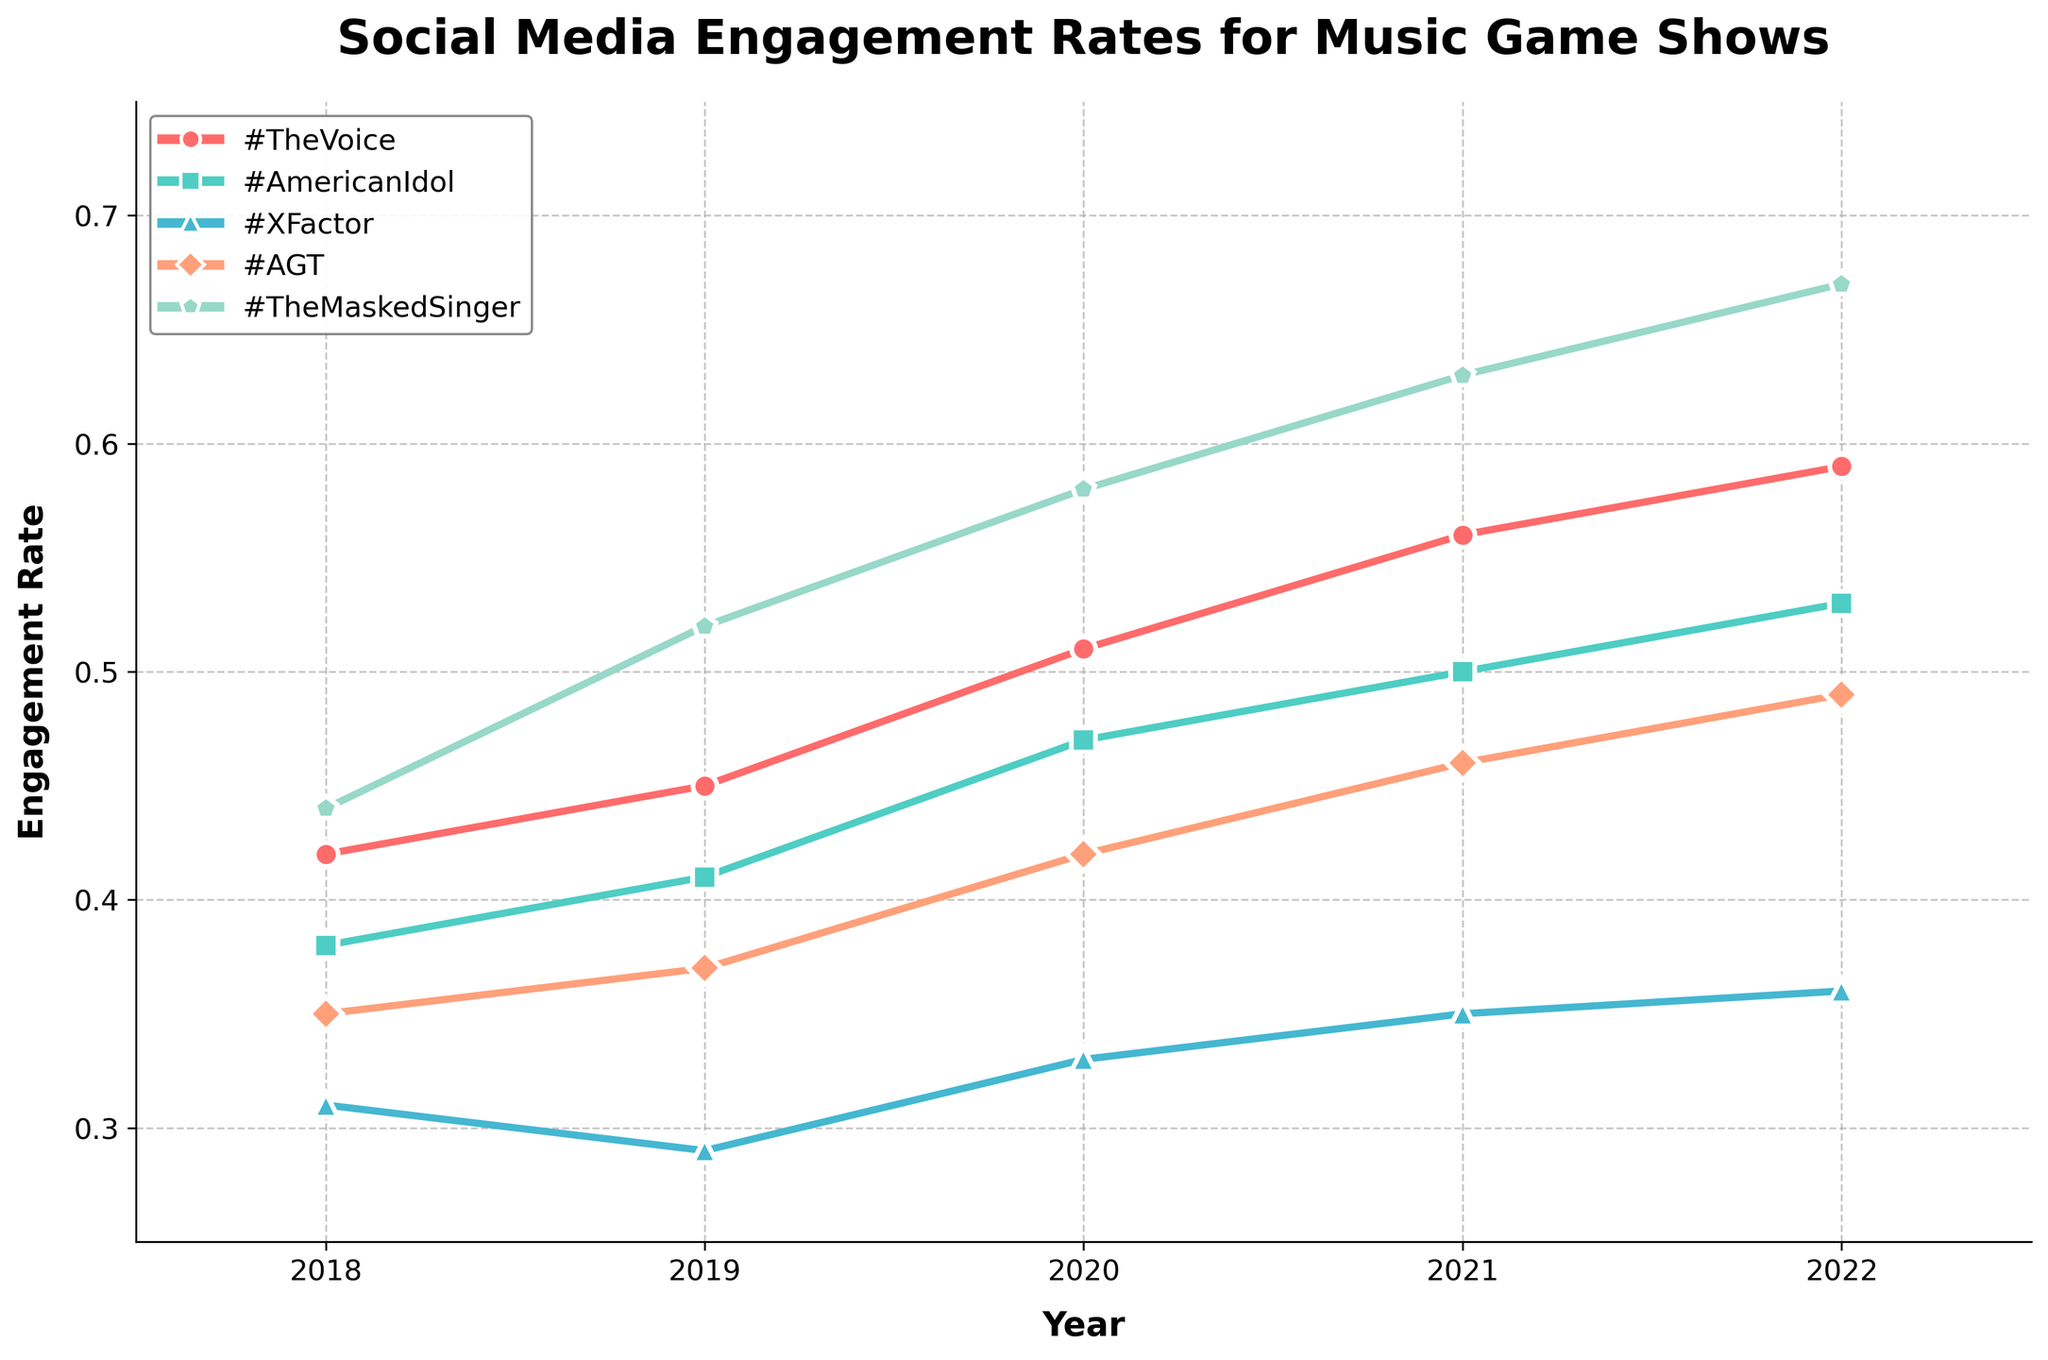What's the trend of the engagement rate for #TheVoice over the years? The engagement rate for #TheVoice shows an increasing trend over the years. By examining the line representing #TheVoice, we see that it starts from a lower value in 2018 and consistently goes up each year, reaching higher values in 2022.
Answer: Increasing Which show had the highest engagement rate in 2022? Looking at the engagement rates for different shows in 2022, #TheMaskedSinger has the highest engagement rate because its line ends at the topmost position compared to the others.
Answer: #TheMaskedSinger Between #AmericanIdol and #XFactor, which show had a lower engagement rate in 2020? Comparing the points for #AmericanIdol and #XFactor in the year 2020, the engagement rate for #XFactor is lower because its point is visibly below the point for #AmericanIdol.
Answer: #XFactor What is the average engagement rate for #AGT from 2018 to 2022? To find the average, sum the engagement rates for #AGT over the years: (0.35 + 0.37 + 0.42 + 0.46 + 0.49) = 2.09. Then divide by the number of years, 5. 2.09 / 5 = 0.418.
Answer: 0.418 In which year did #TheMaskedSinger see the greatest increase in engagement rate compared to the previous year? Calculate the year-over-year increase: 2019-2018 (0.52-0.44 = 0.08), 2020-2019 (0.58-0.52 = 0.06), 2021-2020 (0.63-0.58 = 0.05), 2022-2021 (0.67-0.63 = 0.04). The greatest increase is from 2018 to 2019, which is 0.08.
Answer: 2019 Which show has the most consistent engagement rate over the years? Consistency can be gauged through the least fluctuation in points over the years. By visual inspection, #XFactor appears to have the most consistent, nearly straight, and least varied line among all the shows.
Answer: #XFactor How much higher was the engagement rate for #TheVoice compared to #AGT in 2021? The engagement rate for #TheVoice in 2021 was 0.56, and for #AGT it was 0.46. The difference is 0.56 - 0.46 = 0.10.
Answer: 0.10 What was the lowest engagement rate recorded across all shows from 2018 to 2022? To find the lowest engagement rate, observe all the points and lines across the years. The lowest value is 0.29 for #XFactor in 2019.
Answer: 0.29 Which show had a continuous increase in engagement rate every year? By examining the lines, #TheMaskedSinger shows a continuous increase every year from 2018 to 2022 with its engagement rate always going up.
Answer: #TheMaskedSinger 